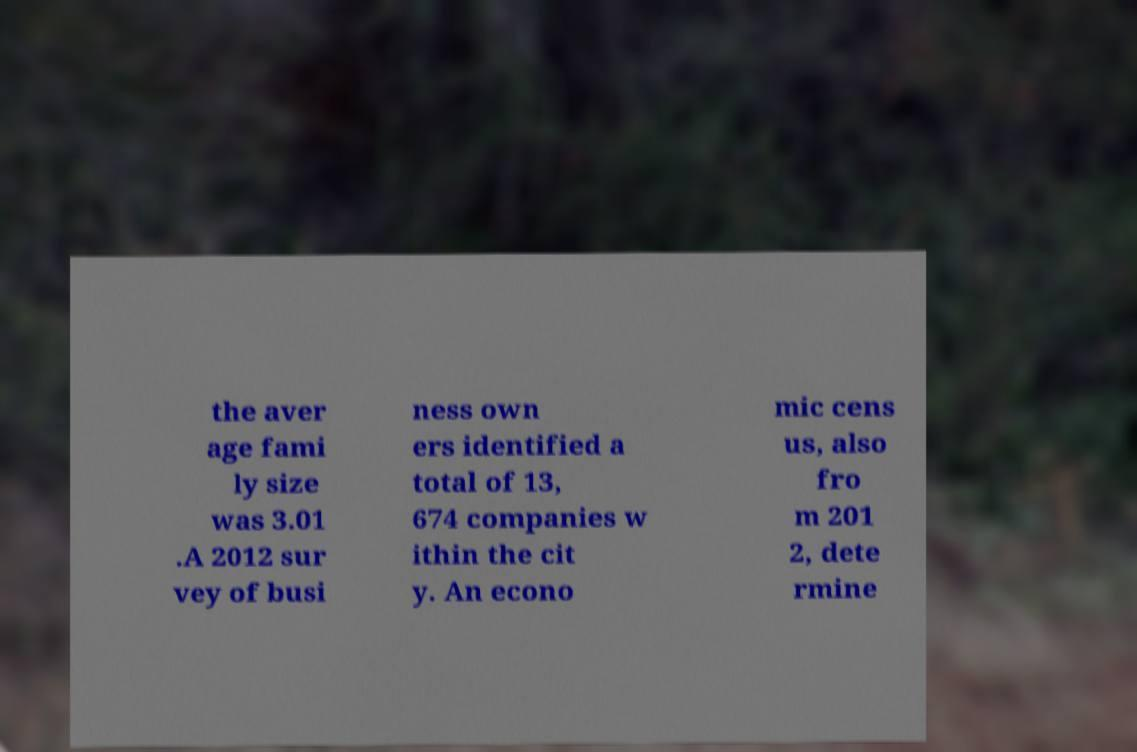There's text embedded in this image that I need extracted. Can you transcribe it verbatim? the aver age fami ly size was 3.01 .A 2012 sur vey of busi ness own ers identified a total of 13, 674 companies w ithin the cit y. An econo mic cens us, also fro m 201 2, dete rmine 